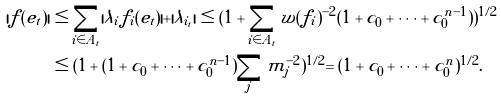<formula> <loc_0><loc_0><loc_500><loc_500>| f ( e _ { t } ) | & \leq \sum _ { i \in A _ { t } } | \lambda _ { i } f _ { i } ( e _ { t } ) | + | \lambda _ { i _ { t } } | \leq ( 1 + \sum _ { i \in A _ { t } } w ( f _ { i } ) ^ { - 2 } ( 1 + c _ { 0 } + \dots + c _ { 0 } ^ { n - 1 } ) ) ^ { 1 / 2 } \\ & \leq ( 1 + ( 1 + c _ { 0 } + \dots + c _ { 0 } ^ { n - 1 } ) \sum _ { j } m _ { j } ^ { - 2 } ) ^ { 1 / 2 } = ( 1 + c _ { 0 } + \dots + c _ { 0 } ^ { n } ) ^ { 1 / 2 } .</formula> 